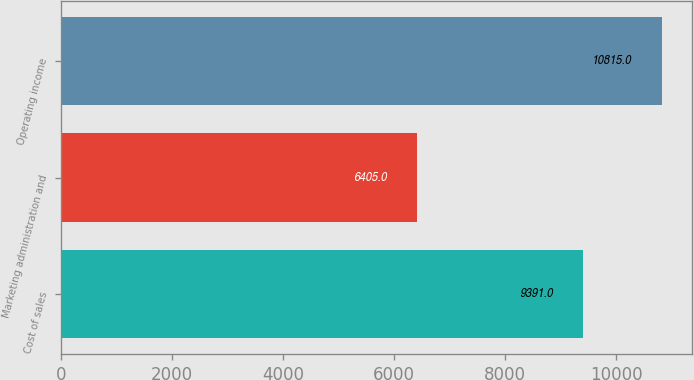<chart> <loc_0><loc_0><loc_500><loc_500><bar_chart><fcel>Cost of sales<fcel>Marketing administration and<fcel>Operating income<nl><fcel>9391<fcel>6405<fcel>10815<nl></chart> 